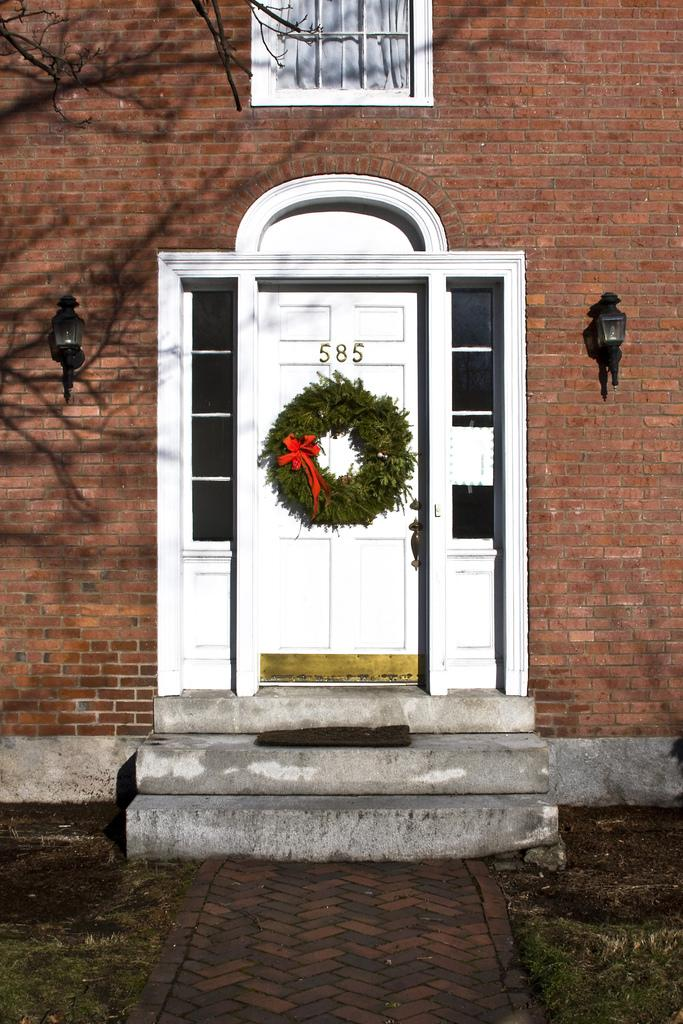What type of structure is in the image? There is a building in the image. What can be seen on the building? Lights are visible on the building. What is a feature of the building that allows access? There is a door on the building. What decoration is on the door? A bay leaf garland is present on the door. What is located near the door? There is a mat in the image. What type of vegetation is in the image? There is a tree and grass visible in the image. How many bikes are parked near the tree in the image? There are no bikes present in the image. What type of love is expressed by the tree in the image? The image does not depict any expression of love; it features a building, lights, a door, a bay leaf garland, a mat, and grass. 